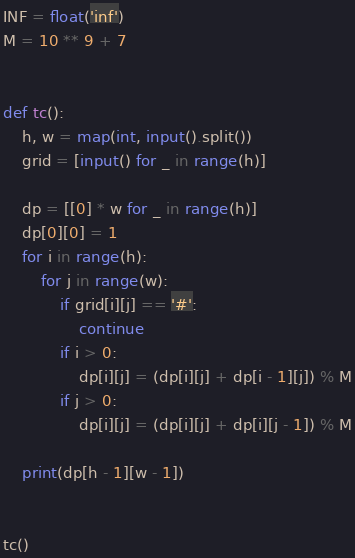<code> <loc_0><loc_0><loc_500><loc_500><_Python_>

INF = float('inf')
M = 10 ** 9 + 7


def tc():
    h, w = map(int, input().split())
    grid = [input() for _ in range(h)]

    dp = [[0] * w for _ in range(h)]
    dp[0][0] = 1
    for i in range(h):
        for j in range(w):
            if grid[i][j] == '#':
                continue
            if i > 0:
                dp[i][j] = (dp[i][j] + dp[i - 1][j]) % M
            if j > 0:
                dp[i][j] = (dp[i][j] + dp[i][j - 1]) % M

    print(dp[h - 1][w - 1])


tc()
</code> 